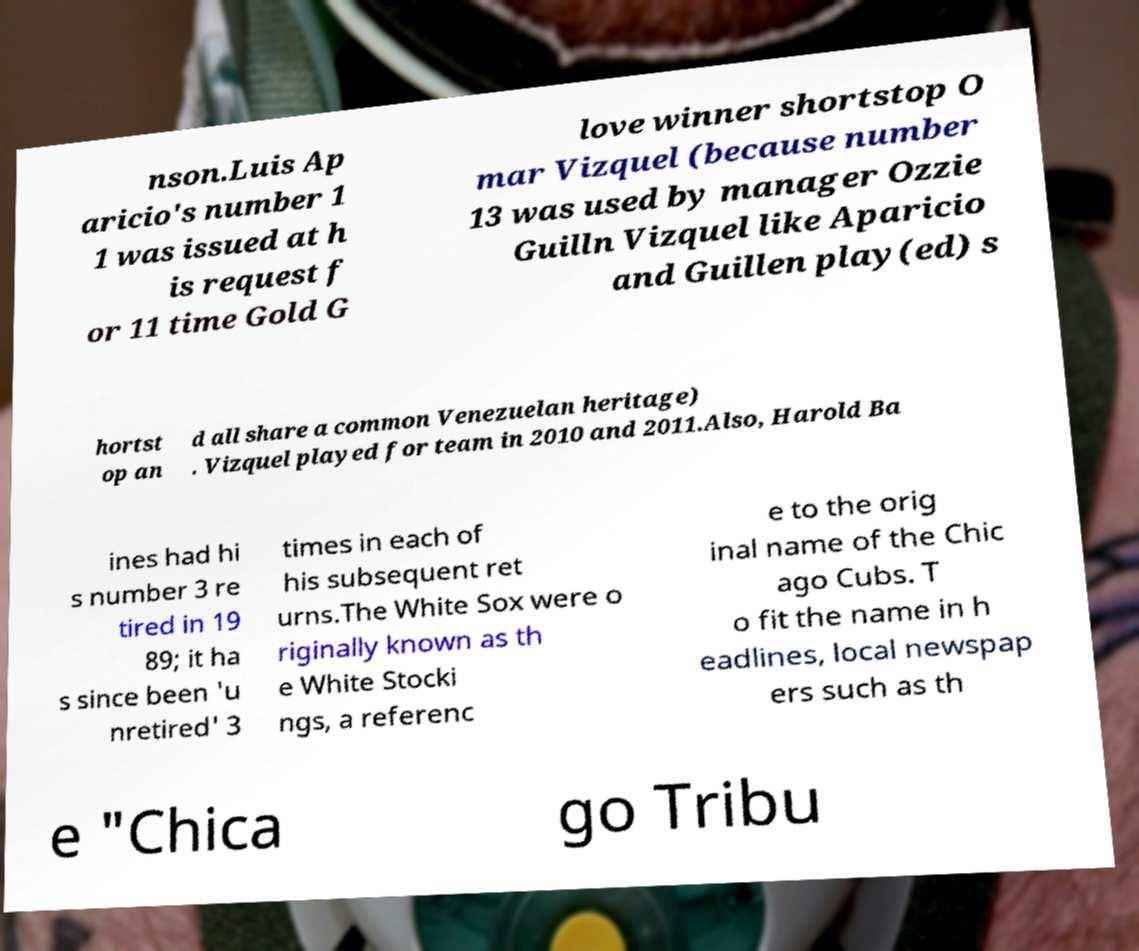For documentation purposes, I need the text within this image transcribed. Could you provide that? nson.Luis Ap aricio's number 1 1 was issued at h is request f or 11 time Gold G love winner shortstop O mar Vizquel (because number 13 was used by manager Ozzie Guilln Vizquel like Aparicio and Guillen play(ed) s hortst op an d all share a common Venezuelan heritage) . Vizquel played for team in 2010 and 2011.Also, Harold Ba ines had hi s number 3 re tired in 19 89; it ha s since been 'u nretired' 3 times in each of his subsequent ret urns.The White Sox were o riginally known as th e White Stocki ngs, a referenc e to the orig inal name of the Chic ago Cubs. T o fit the name in h eadlines, local newspap ers such as th e "Chica go Tribu 